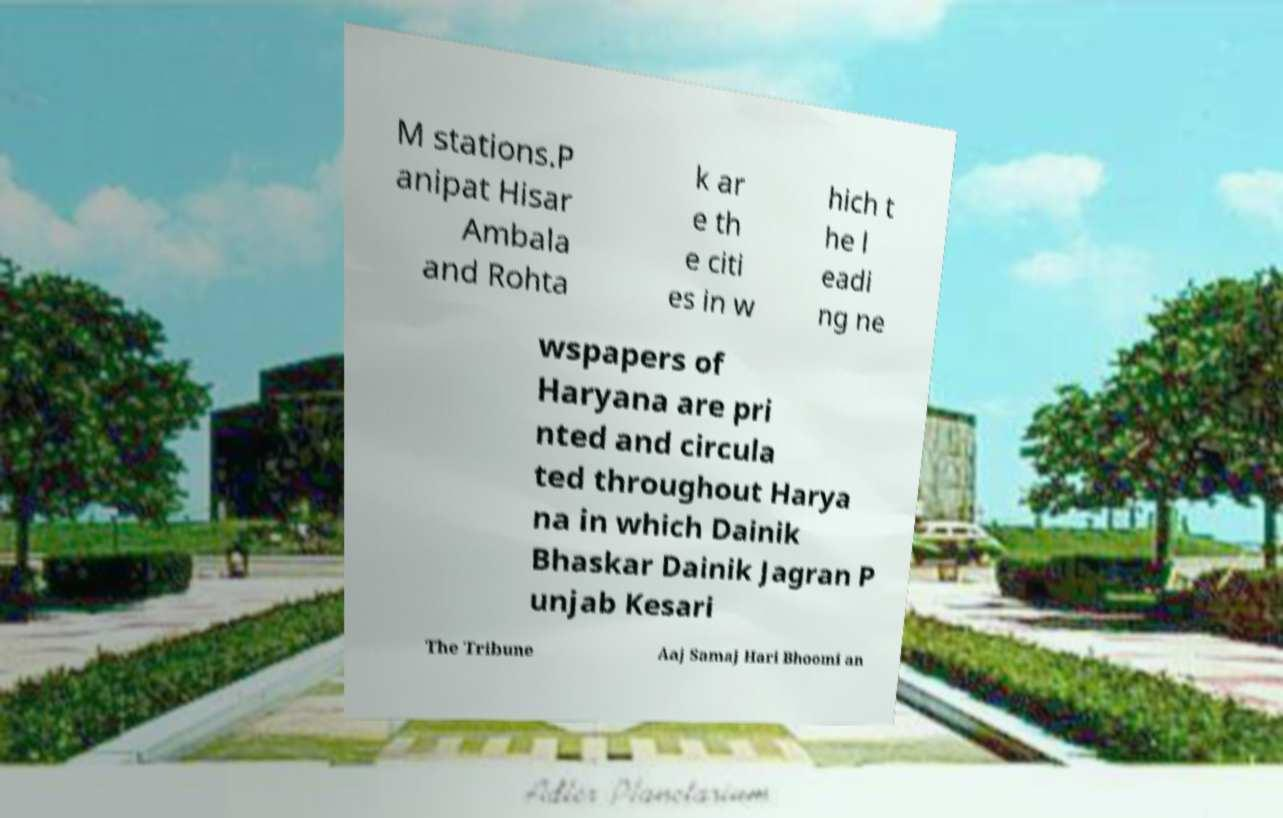Could you extract and type out the text from this image? M stations.P anipat Hisar Ambala and Rohta k ar e th e citi es in w hich t he l eadi ng ne wspapers of Haryana are pri nted and circula ted throughout Harya na in which Dainik Bhaskar Dainik Jagran P unjab Kesari The Tribune Aaj Samaj Hari Bhoomi an 